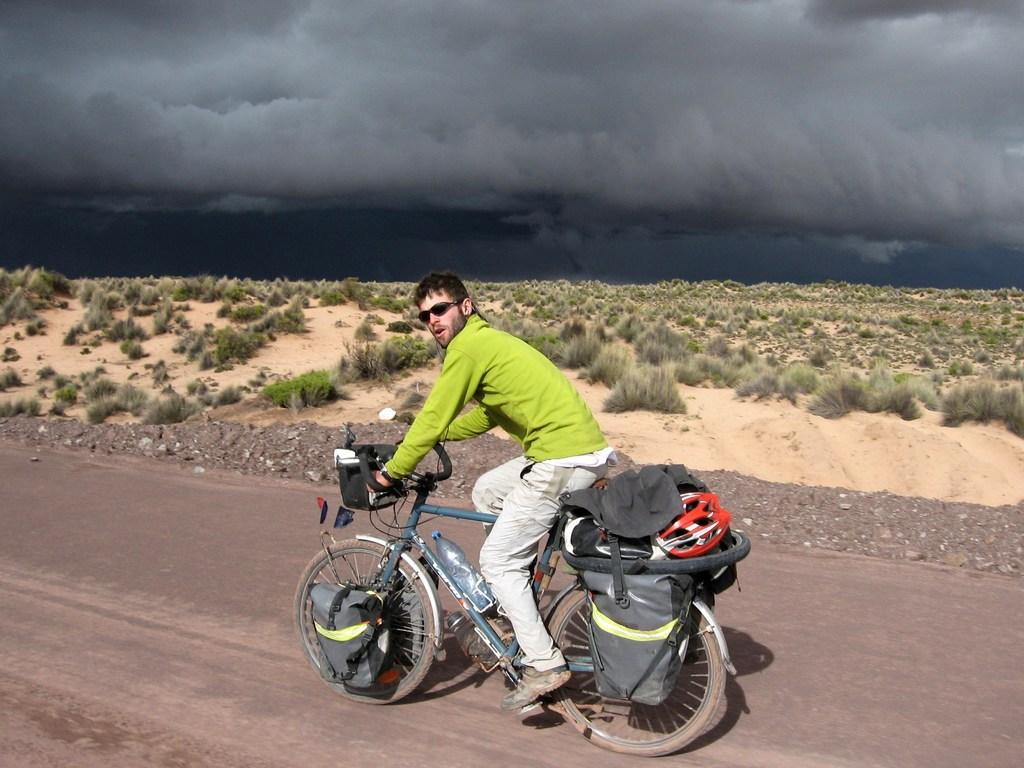What can be seen in the background of the image? There is a sky in the image. What type of vegetation is present in the image? There is grass in the image. What object is visible in the image that might be used for carrying items? There is a bag in the image. What activity is the man in the image engaged in? There is a man riding a bicycle in the image. What grade is the man riding the bicycle in the image? There is no indication of a grade or educational level in the image; it simply shows a man riding a bicycle. How does the hook in the image help the man ride the bicycle? There is no hook present in the image; it only features a man riding a bicycle and the other mentioned elements. 